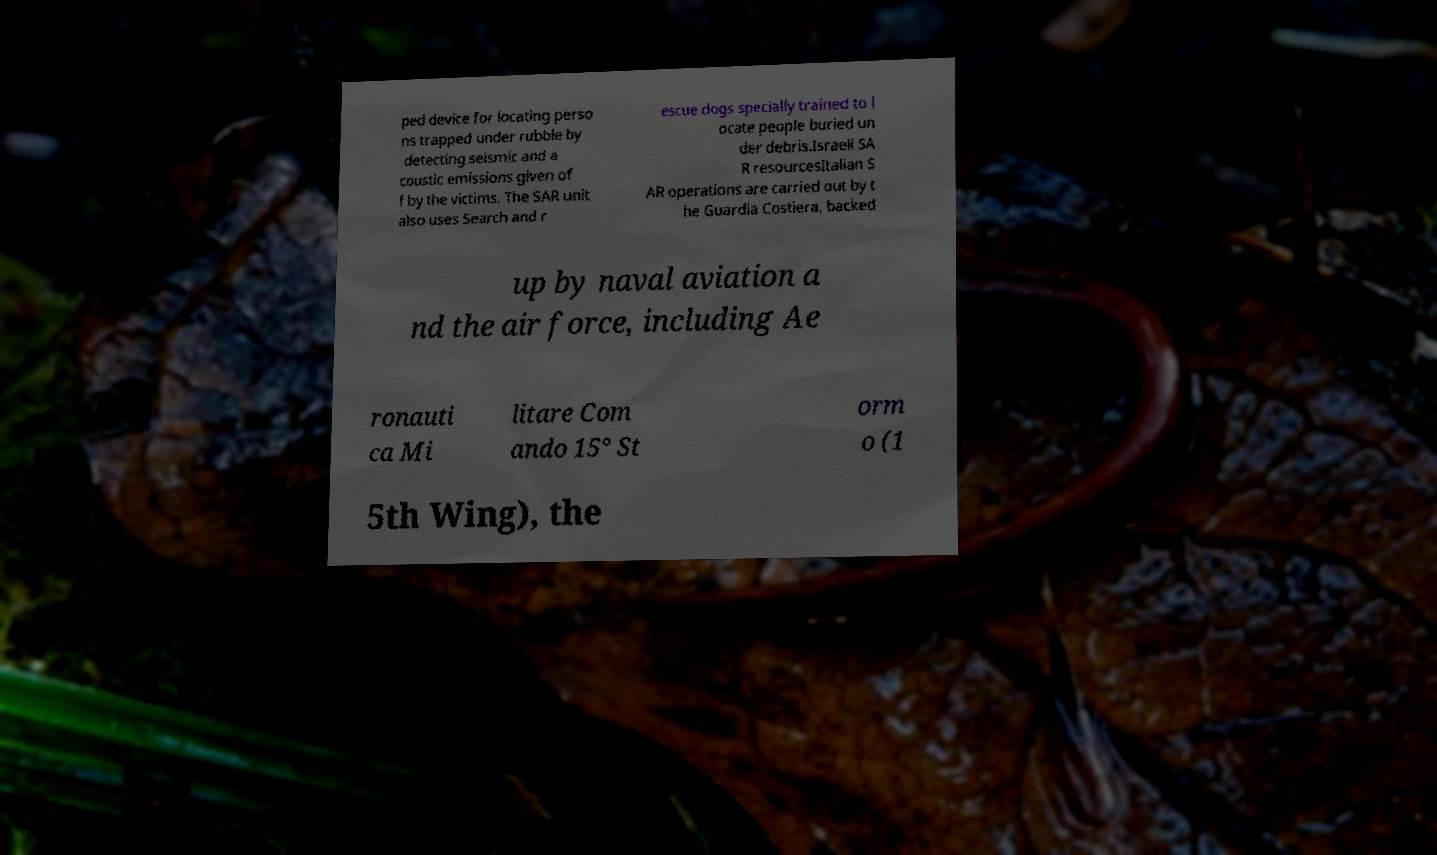I need the written content from this picture converted into text. Can you do that? ped device for locating perso ns trapped under rubble by detecting seismic and a coustic emissions given of f by the victims. The SAR unit also uses Search and r escue dogs specially trained to l ocate people buried un der debris.Israeli SA R resourcesItalian S AR operations are carried out by t he Guardia Costiera, backed up by naval aviation a nd the air force, including Ae ronauti ca Mi litare Com ando 15° St orm o (1 5th Wing), the 